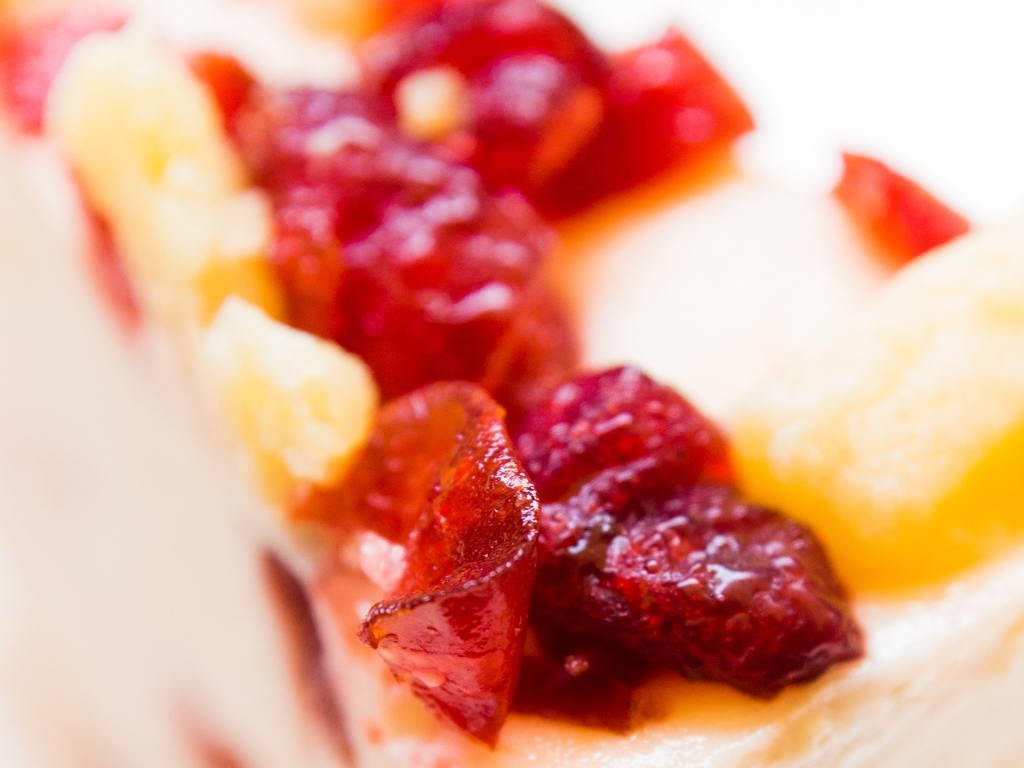How are the details and textures on the objects' surfaces?
A. Indistinct
B. Clear
C. Blurred
Answer with the option's letter from the given choices directly.
 B. 